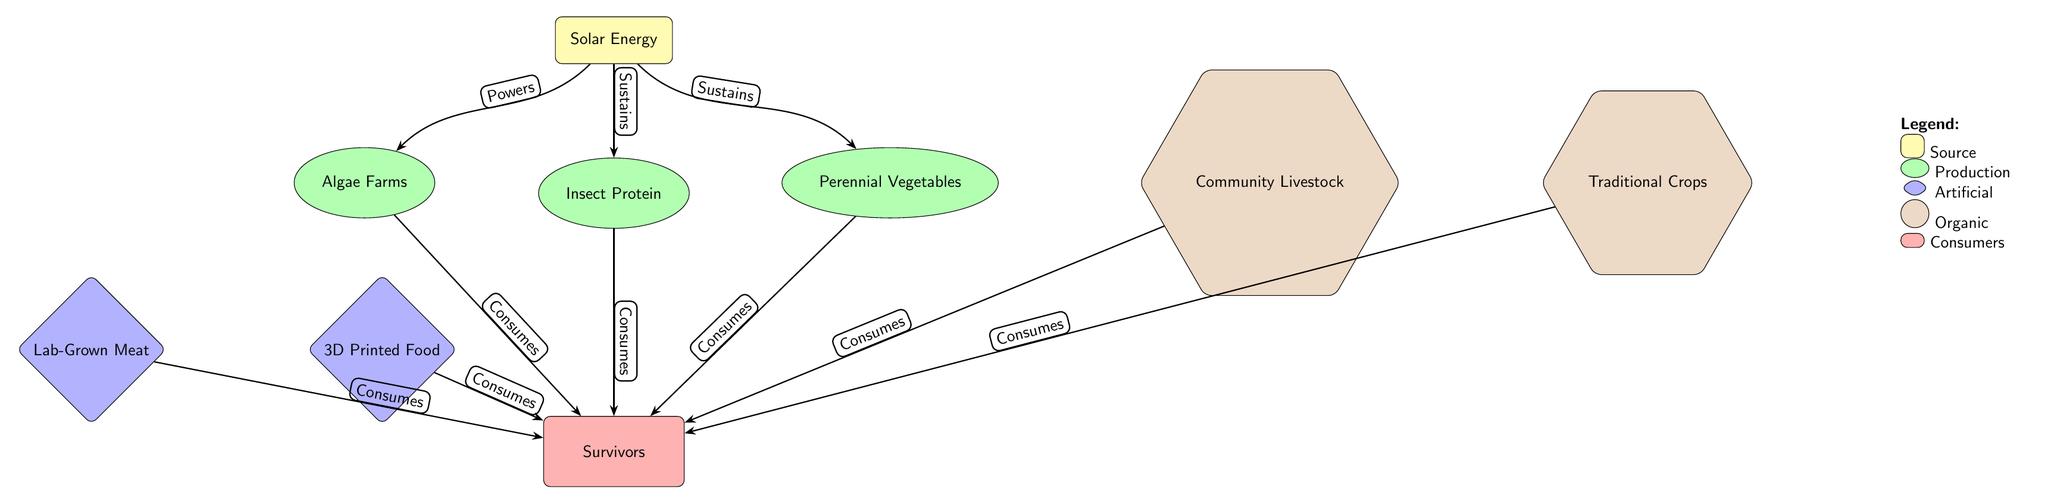What is the source of energy in this food chain? The diagram indicates that the source of energy is "Solar Energy," which is represented at the top of the hierarchy. This node is connected to the production nodes below it, illustrating its role as the foundational energy source.
Answer: Solar Energy How many production nodes are present in the diagram? By counting the shapes labeled as production nodes, we find "Algae Farms," "Insect Protein," and "Perennial Vegetables," resulting in a total of three production nodes shown in the diagram.
Answer: 3 Which type of food source is represented by "Lab-Grown Meat"? The diagram clearly categorizes "Lab-Grown Meat" under the artificial food sources, which is represented as a diamond shape. This specific food source falls into the artificial category of food production.
Answer: Artificial What do "Community Livestock" and "Traditional Crops" have in common? Both "Community Livestock" and "Traditional Crops" are categorized under organic food sources, which are depicted as hexagonal shapes in the diagram. They share the characteristic of being organic in nature and are directed towards nourishing the consumers.
Answer: Organic Which production source directly sustains "Perennial Vegetables"? The diagram shows an arrow that connects "Solar Energy" to "Perennial Vegetables," indicating that the energy from solar power directly sustains the growth or production of this food source.
Answer: Solar Energy How many consumers are identified in the diagram? The diagram specifies only one consumer node labeled "Survivors," which collects resources from the various production nodes indicated in the diagram. Thus, counting leads us to one consumer.
Answer: 1 What ethical dilemma might arise between artificial and organic food sources? The dilemma stems from the potential trade-offs between resource efficiency of artificial sources and the health or environmental benefits of organic sources, creating a complex moral decision-making scenario in a survival context.
Answer: Trade-offs Which production source is sustained by "Insect Protein"? The diagram illustrates that all production sources including "Algae Farms," "Insect Protein," and "Perennial Vegetables" directly consume energy from "Solar Energy," but does not specify that "Insect Protein" is sustained by anything other than "Solar Energy." Hence, the answer revolves around the common energy source.
Answer: Solar Energy How do consumers interact with artificial food sources in the diagram? The diagram links the artificial food sources "3D Printed Food" and "Lab-Grown Meat" to the consumer node "Survivors," indicating that both types of artificial food are directed towards the consumers for nourishment.
Answer: Consumes 